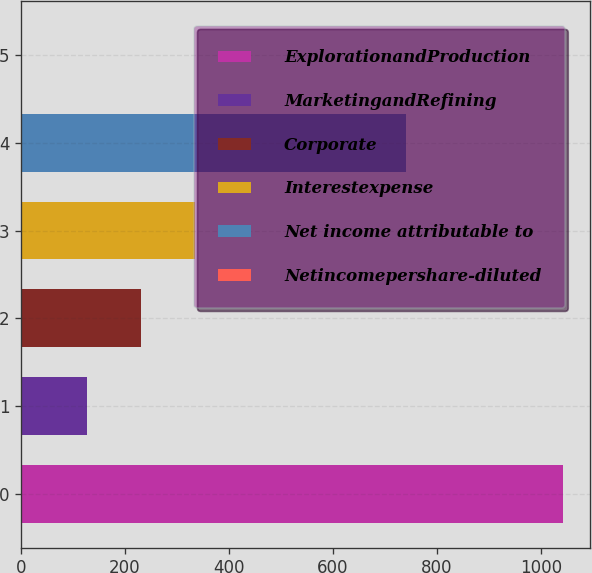<chart> <loc_0><loc_0><loc_500><loc_500><bar_chart><fcel>ExplorationandProduction<fcel>MarketingandRefining<fcel>Corporate<fcel>Interestexpense<fcel>Net income attributable to<fcel>Netincomepershare-diluted<nl><fcel>1042<fcel>127<fcel>230.97<fcel>334.94<fcel>740<fcel>2.27<nl></chart> 